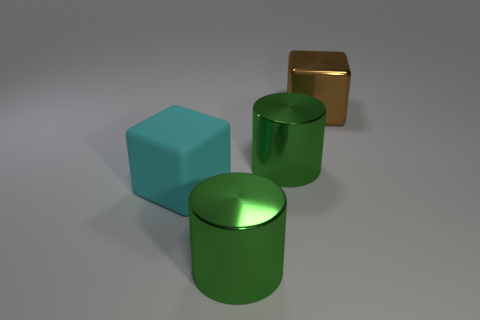Add 3 small spheres. How many objects exist? 7 Subtract 2 cylinders. How many cylinders are left? 0 Subtract all brown blocks. How many blocks are left? 1 Subtract all brown cubes. Subtract all purple spheres. How many cubes are left? 1 Subtract all big cylinders. Subtract all big brown metal cubes. How many objects are left? 1 Add 3 big green metallic cylinders. How many big green metallic cylinders are left? 5 Add 2 large rubber cylinders. How many large rubber cylinders exist? 2 Subtract 0 purple spheres. How many objects are left? 4 